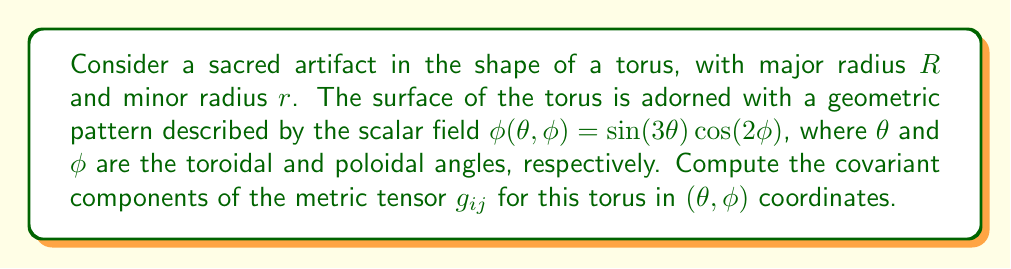Give your solution to this math problem. To compute the metric tensor for the torus, we'll follow these steps:

1) First, we need to express the Cartesian coordinates $(x, y, z)$ in terms of the toroidal coordinates $(\theta, \phi)$:

   $$x = (R + r\cos\phi)\cos\theta$$
   $$y = (R + r\cos\phi)\sin\theta$$
   $$z = r\sin\phi$$

2) The metric tensor is given by $g_{ij} = \frac{\partial \vec{r}}{\partial u^i} \cdot \frac{\partial \vec{r}}{\partial u^j}$, where $\vec{r} = (x, y, z)$ and $(u^1, u^2) = (\theta, \phi)$.

3) Let's compute the partial derivatives:

   $$\frac{\partial \vec{r}}{\partial \theta} = (-(R + r\cos\phi)\sin\theta, (R + r\cos\phi)\cos\theta, 0)$$
   $$\frac{\partial \vec{r}}{\partial \phi} = (-r\sin\phi\cos\theta, -r\sin\phi\sin\theta, r\cos\phi)$$

4) Now we can compute the components of the metric tensor:

   $$g_{\theta\theta} = \frac{\partial \vec{r}}{\partial \theta} \cdot \frac{\partial \vec{r}}{\partial \theta} = (R + r\cos\phi)^2$$

   $$g_{\phi\phi} = \frac{\partial \vec{r}}{\partial \phi} \cdot \frac{\partial \vec{r}}{\partial \phi} = r^2$$

   $$g_{\theta\phi} = g_{\phi\theta} = \frac{\partial \vec{r}}{\partial \theta} \cdot \frac{\partial \vec{r}}{\partial \phi} = 0$$

5) Therefore, the metric tensor in matrix form is:

   $$g_{ij} = \begin{pmatrix}
   (R + r\cos\phi)^2 & 0 \\
   0 & r^2
   \end{pmatrix}$$

This metric tensor describes the geometry of the torus surface, which is crucial for understanding how the geometric pattern $\phi(\theta, \phi)$ is mapped onto the sacred artifact.
Answer: $$g_{ij} = \begin{pmatrix}
(R + r\cos\phi)^2 & 0 \\
0 & r^2
\end{pmatrix}$$ 